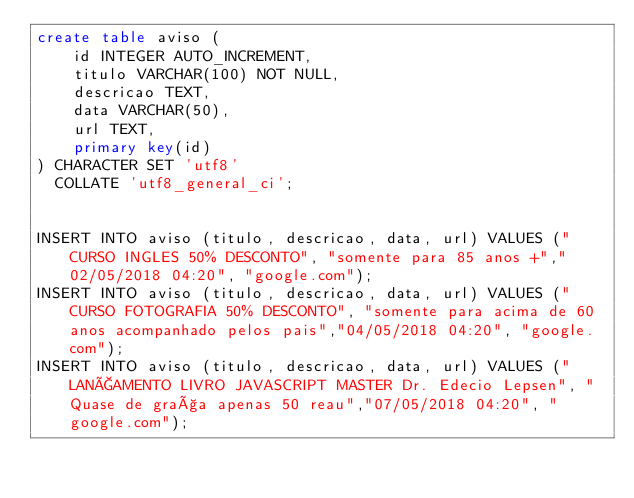<code> <loc_0><loc_0><loc_500><loc_500><_SQL_>create table aviso (
    id INTEGER AUTO_INCREMENT,
    titulo VARCHAR(100) NOT NULL,
    descricao TEXT,
    data VARCHAR(50),
    url TEXT,
    primary key(id)
) CHARACTER SET 'utf8' 
  COLLATE 'utf8_general_ci';


INSERT INTO aviso (titulo, descricao, data, url) VALUES ("CURSO INGLES 50% DESCONTO", "somente para 85 anos +","02/05/2018 04:20", "google.com");
INSERT INTO aviso (titulo, descricao, data, url) VALUES ("CURSO FOTOGRAFIA 50% DESCONTO", "somente para acima de 60 anos acompanhado pelos pais","04/05/2018 04:20", "google.com");
INSERT INTO aviso (titulo, descricao, data, url) VALUES ("LANÇAMENTO LIVRO JAVASCRIPT MASTER Dr. Edecio Lepsen", "Quase de graça apenas 50 reau","07/05/2018 04:20", "google.com");</code> 